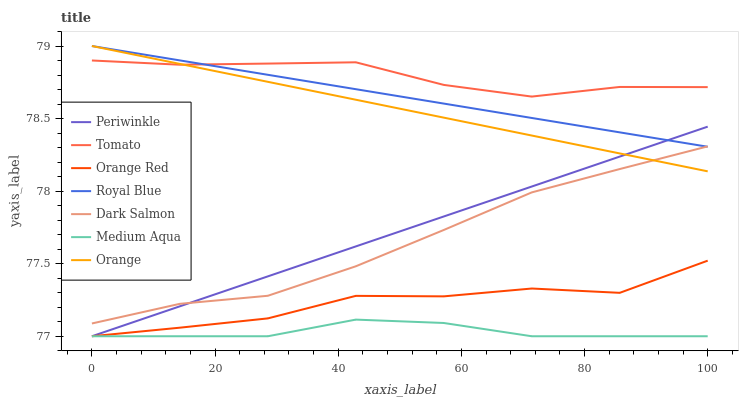Does Medium Aqua have the minimum area under the curve?
Answer yes or no. Yes. Does Tomato have the maximum area under the curve?
Answer yes or no. Yes. Does Dark Salmon have the minimum area under the curve?
Answer yes or no. No. Does Dark Salmon have the maximum area under the curve?
Answer yes or no. No. Is Periwinkle the smoothest?
Answer yes or no. Yes. Is Orange Red the roughest?
Answer yes or no. Yes. Is Dark Salmon the smoothest?
Answer yes or no. No. Is Dark Salmon the roughest?
Answer yes or no. No. Does Dark Salmon have the lowest value?
Answer yes or no. No. Does Dark Salmon have the highest value?
Answer yes or no. No. Is Orange Red less than Dark Salmon?
Answer yes or no. Yes. Is Tomato greater than Dark Salmon?
Answer yes or no. Yes. Does Orange Red intersect Dark Salmon?
Answer yes or no. No. 